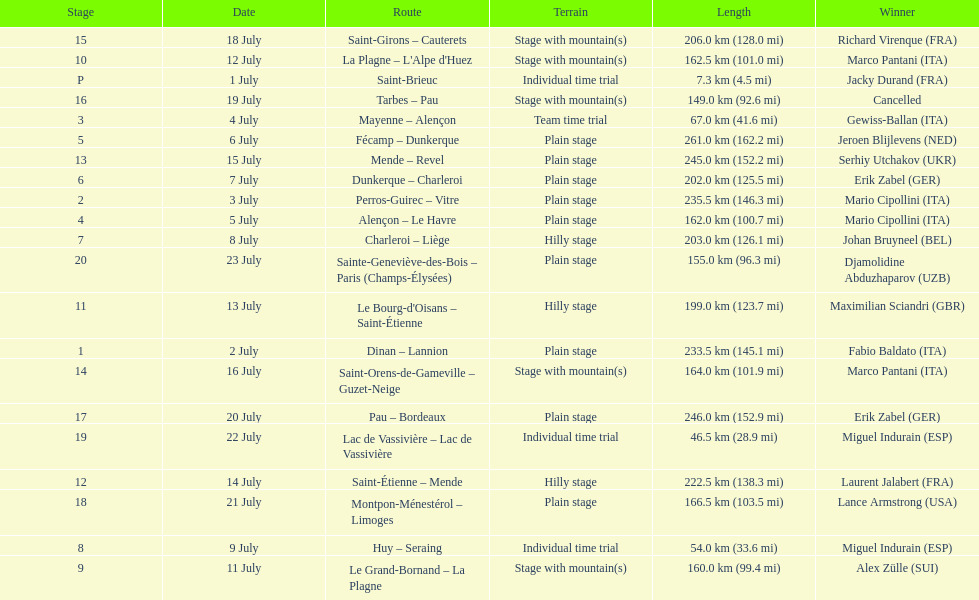How much longer is the 20th tour de france stage than the 19th? 108.5 km. 